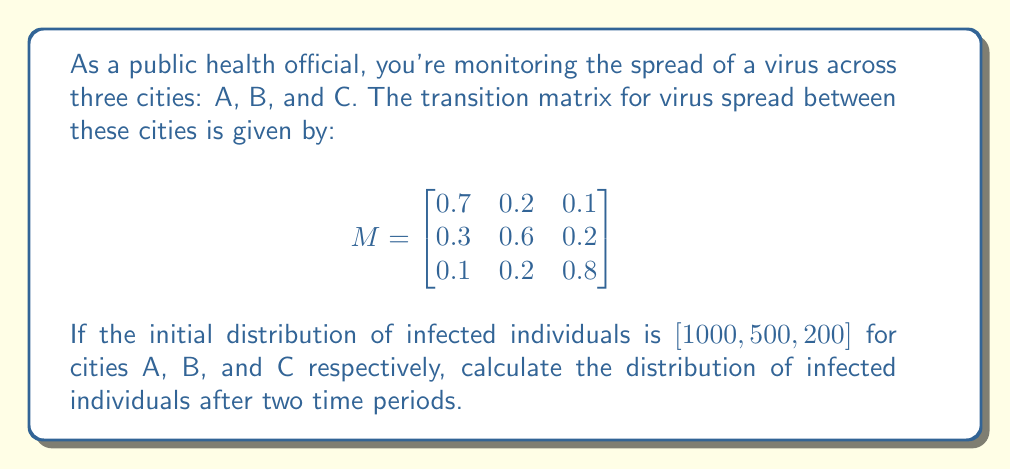Could you help me with this problem? Let's approach this step-by-step:

1) First, let's understand what the matrix represents. Each column represents the probability of the virus spreading from one city to another. For example, the first column shows that 70% of infections in city A stay in A, 30% spread to B, and 10% to C.

2) The initial distribution is given as a row vector:
   $$v_0 = \begin{bmatrix} 1000 & 500 & 200 \end{bmatrix}$$

3) To find the distribution after one time period, we multiply this vector by the transition matrix:
   $$v_1 = v_0 M = \begin{bmatrix} 1000 & 500 & 200 \end{bmatrix} \begin{bmatrix}
   0.7 & 0.2 & 0.1 \\
   0.3 & 0.6 & 0.2 \\
   0.1 & 0.2 & 0.8
   \end{bmatrix}$$

4) Performing this multiplication:
   $$v_1 = \begin{bmatrix} 850 & 450 & 400 \end{bmatrix}$$

5) To find the distribution after two time periods, we multiply $v_1$ by M again:
   $$v_2 = v_1 M = \begin{bmatrix} 850 & 450 & 400 \end{bmatrix} \begin{bmatrix}
   0.7 & 0.2 & 0.1 \\
   0.3 & 0.6 & 0.2 \\
   0.1 & 0.2 & 0.8
   \end{bmatrix}$$

6) Performing this multiplication:
   $$v_2 = \begin{bmatrix} 755 & 465 & 480 \end{bmatrix}$$

7) Rounding to the nearest whole number (as we're dealing with individuals):
   $$v_2 \approx \begin{bmatrix} 755 & 465 & 480 \end{bmatrix}$$
Answer: $[755, 465, 480]$ 